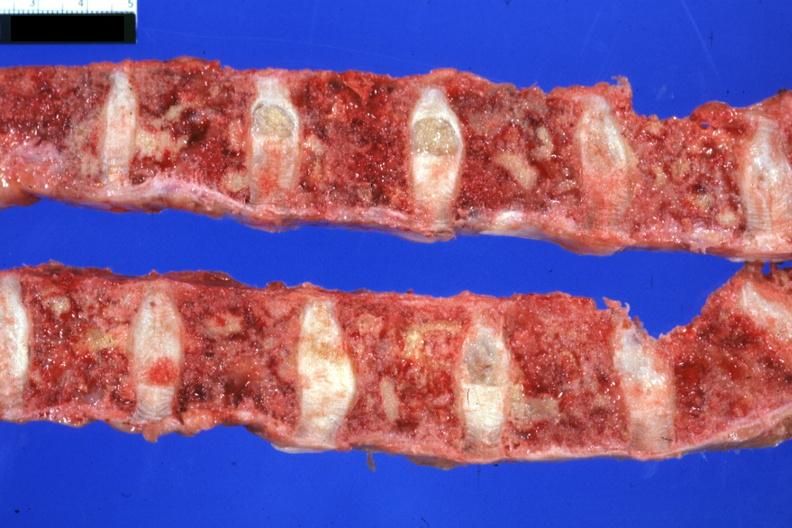what does this image show?
Answer the question using a single word or phrase. Excellent multiple lesions sigmoid colon papillary adenocarcinoma 6mo post colon resection with multiple complications 